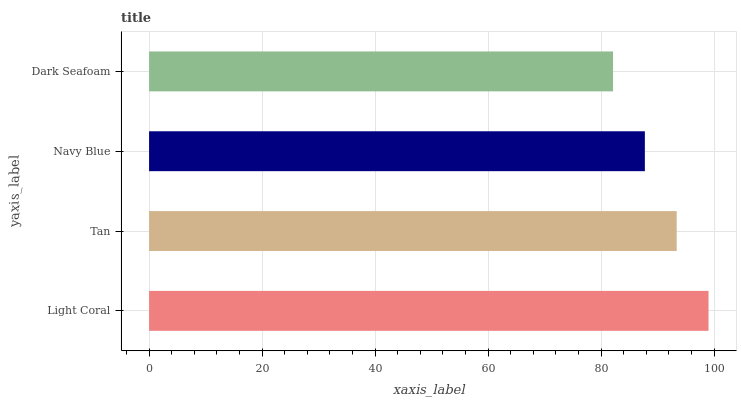Is Dark Seafoam the minimum?
Answer yes or no. Yes. Is Light Coral the maximum?
Answer yes or no. Yes. Is Tan the minimum?
Answer yes or no. No. Is Tan the maximum?
Answer yes or no. No. Is Light Coral greater than Tan?
Answer yes or no. Yes. Is Tan less than Light Coral?
Answer yes or no. Yes. Is Tan greater than Light Coral?
Answer yes or no. No. Is Light Coral less than Tan?
Answer yes or no. No. Is Tan the high median?
Answer yes or no. Yes. Is Navy Blue the low median?
Answer yes or no. Yes. Is Dark Seafoam the high median?
Answer yes or no. No. Is Light Coral the low median?
Answer yes or no. No. 